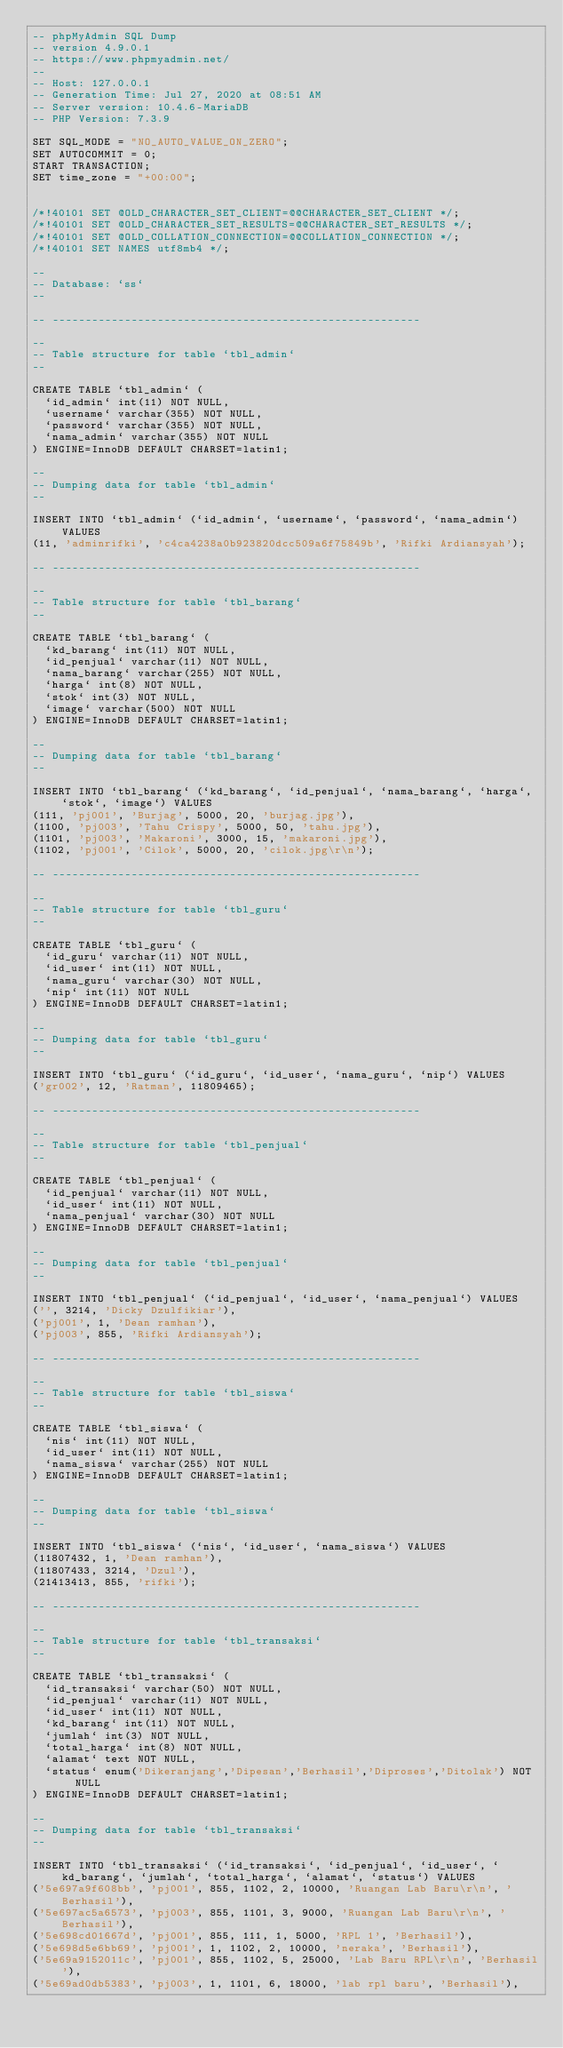Convert code to text. <code><loc_0><loc_0><loc_500><loc_500><_SQL_>-- phpMyAdmin SQL Dump
-- version 4.9.0.1
-- https://www.phpmyadmin.net/
--
-- Host: 127.0.0.1
-- Generation Time: Jul 27, 2020 at 08:51 AM
-- Server version: 10.4.6-MariaDB
-- PHP Version: 7.3.9

SET SQL_MODE = "NO_AUTO_VALUE_ON_ZERO";
SET AUTOCOMMIT = 0;
START TRANSACTION;
SET time_zone = "+00:00";


/*!40101 SET @OLD_CHARACTER_SET_CLIENT=@@CHARACTER_SET_CLIENT */;
/*!40101 SET @OLD_CHARACTER_SET_RESULTS=@@CHARACTER_SET_RESULTS */;
/*!40101 SET @OLD_COLLATION_CONNECTION=@@COLLATION_CONNECTION */;
/*!40101 SET NAMES utf8mb4 */;

--
-- Database: `ss`
--

-- --------------------------------------------------------

--
-- Table structure for table `tbl_admin`
--

CREATE TABLE `tbl_admin` (
  `id_admin` int(11) NOT NULL,
  `username` varchar(355) NOT NULL,
  `password` varchar(355) NOT NULL,
  `nama_admin` varchar(355) NOT NULL
) ENGINE=InnoDB DEFAULT CHARSET=latin1;

--
-- Dumping data for table `tbl_admin`
--

INSERT INTO `tbl_admin` (`id_admin`, `username`, `password`, `nama_admin`) VALUES
(11, 'adminrifki', 'c4ca4238a0b923820dcc509a6f75849b', 'Rifki Ardiansyah');

-- --------------------------------------------------------

--
-- Table structure for table `tbl_barang`
--

CREATE TABLE `tbl_barang` (
  `kd_barang` int(11) NOT NULL,
  `id_penjual` varchar(11) NOT NULL,
  `nama_barang` varchar(255) NOT NULL,
  `harga` int(8) NOT NULL,
  `stok` int(3) NOT NULL,
  `image` varchar(500) NOT NULL
) ENGINE=InnoDB DEFAULT CHARSET=latin1;

--
-- Dumping data for table `tbl_barang`
--

INSERT INTO `tbl_barang` (`kd_barang`, `id_penjual`, `nama_barang`, `harga`, `stok`, `image`) VALUES
(111, 'pj001', 'Burjag', 5000, 20, 'burjag.jpg'),
(1100, 'pj003', 'Tahu Crispy', 5000, 50, 'tahu.jpg'),
(1101, 'pj003', 'Makaroni', 3000, 15, 'makaroni.jpg'),
(1102, 'pj001', 'Cilok', 5000, 20, 'cilok.jpg\r\n');

-- --------------------------------------------------------

--
-- Table structure for table `tbl_guru`
--

CREATE TABLE `tbl_guru` (
  `id_guru` varchar(11) NOT NULL,
  `id_user` int(11) NOT NULL,
  `nama_guru` varchar(30) NOT NULL,
  `nip` int(11) NOT NULL
) ENGINE=InnoDB DEFAULT CHARSET=latin1;

--
-- Dumping data for table `tbl_guru`
--

INSERT INTO `tbl_guru` (`id_guru`, `id_user`, `nama_guru`, `nip`) VALUES
('gr002', 12, 'Ratman', 11809465);

-- --------------------------------------------------------

--
-- Table structure for table `tbl_penjual`
--

CREATE TABLE `tbl_penjual` (
  `id_penjual` varchar(11) NOT NULL,
  `id_user` int(11) NOT NULL,
  `nama_penjual` varchar(30) NOT NULL
) ENGINE=InnoDB DEFAULT CHARSET=latin1;

--
-- Dumping data for table `tbl_penjual`
--

INSERT INTO `tbl_penjual` (`id_penjual`, `id_user`, `nama_penjual`) VALUES
('', 3214, 'Dicky Dzulfikiar'),
('pj001', 1, 'Dean ramhan'),
('pj003', 855, 'Rifki Ardiansyah');

-- --------------------------------------------------------

--
-- Table structure for table `tbl_siswa`
--

CREATE TABLE `tbl_siswa` (
  `nis` int(11) NOT NULL,
  `id_user` int(11) NOT NULL,
  `nama_siswa` varchar(255) NOT NULL
) ENGINE=InnoDB DEFAULT CHARSET=latin1;

--
-- Dumping data for table `tbl_siswa`
--

INSERT INTO `tbl_siswa` (`nis`, `id_user`, `nama_siswa`) VALUES
(11807432, 1, 'Dean ramhan'),
(11807433, 3214, 'Dzul'),
(21413413, 855, 'rifki');

-- --------------------------------------------------------

--
-- Table structure for table `tbl_transaksi`
--

CREATE TABLE `tbl_transaksi` (
  `id_transaksi` varchar(50) NOT NULL,
  `id_penjual` varchar(11) NOT NULL,
  `id_user` int(11) NOT NULL,
  `kd_barang` int(11) NOT NULL,
  `jumlah` int(3) NOT NULL,
  `total_harga` int(8) NOT NULL,
  `alamat` text NOT NULL,
  `status` enum('Dikeranjang','Dipesan','Berhasil','Diproses','Ditolak') NOT NULL
) ENGINE=InnoDB DEFAULT CHARSET=latin1;

--
-- Dumping data for table `tbl_transaksi`
--

INSERT INTO `tbl_transaksi` (`id_transaksi`, `id_penjual`, `id_user`, `kd_barang`, `jumlah`, `total_harga`, `alamat`, `status`) VALUES
('5e697a9f608bb', 'pj001', 855, 1102, 2, 10000, 'Ruangan Lab Baru\r\n', 'Berhasil'),
('5e697ac5a6573', 'pj003', 855, 1101, 3, 9000, 'Ruangan Lab Baru\r\n', 'Berhasil'),
('5e698cd01667d', 'pj001', 855, 111, 1, 5000, 'RPL 1', 'Berhasil'),
('5e698d5e6bb69', 'pj001', 1, 1102, 2, 10000, 'neraka', 'Berhasil'),
('5e69a9152011c', 'pj001', 855, 1102, 5, 25000, 'Lab Baru RPL\r\n', 'Berhasil'),
('5e69ad0db5383', 'pj003', 1, 1101, 6, 18000, 'lab rpl baru', 'Berhasil'),</code> 